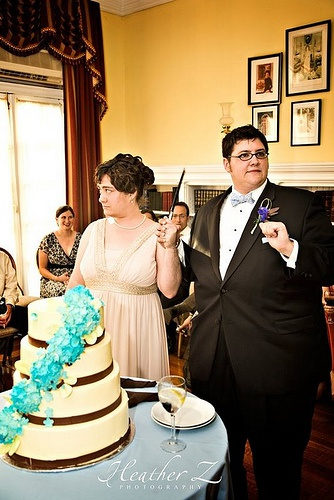Describe the objects in this image and their specific colors. I can see people in black, white, maroon, and tan tones, cake in black, lightyellow, khaki, turquoise, and maroon tones, people in black, ivory, and tan tones, dining table in black, darkgray, lightgray, and ivory tones, and people in black, tan, and maroon tones in this image. 